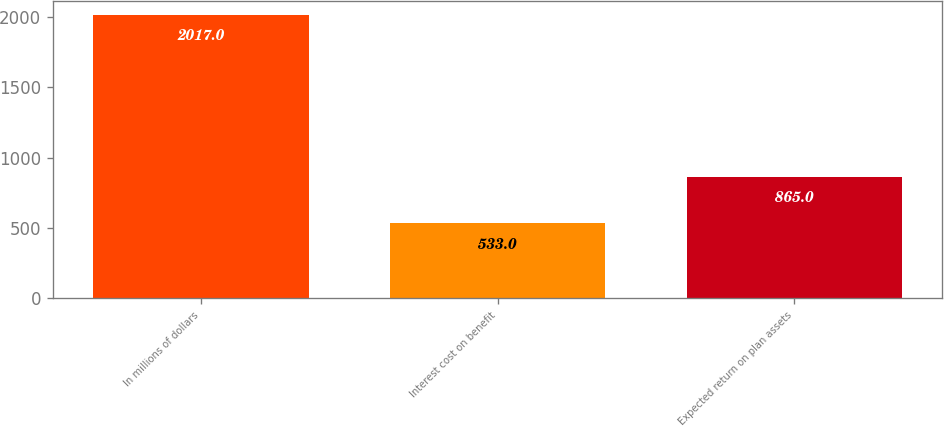Convert chart to OTSL. <chart><loc_0><loc_0><loc_500><loc_500><bar_chart><fcel>In millions of dollars<fcel>Interest cost on benefit<fcel>Expected return on plan assets<nl><fcel>2017<fcel>533<fcel>865<nl></chart> 